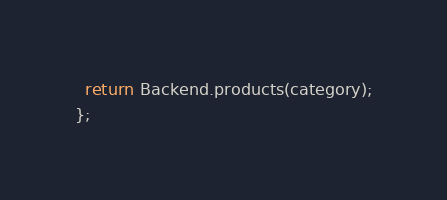Convert code to text. <code><loc_0><loc_0><loc_500><loc_500><_TypeScript_>  return Backend.products(category);
};
</code> 